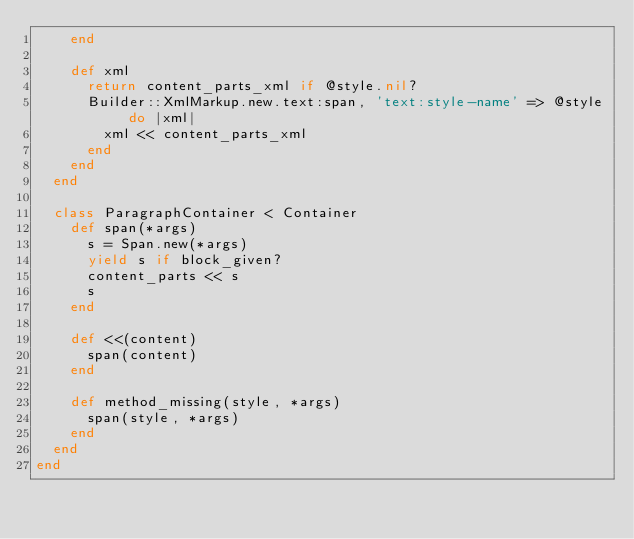Convert code to text. <code><loc_0><loc_0><loc_500><loc_500><_Ruby_>    end

    def xml
      return content_parts_xml if @style.nil?
      Builder::XmlMarkup.new.text:span, 'text:style-name' => @style do |xml|
        xml << content_parts_xml
      end
    end
  end

  class ParagraphContainer < Container
    def span(*args)
      s = Span.new(*args)
      yield s if block_given?
      content_parts << s
      s
    end

    def <<(content)
      span(content)
    end

    def method_missing(style, *args)
      span(style, *args)
    end
  end
end

</code> 